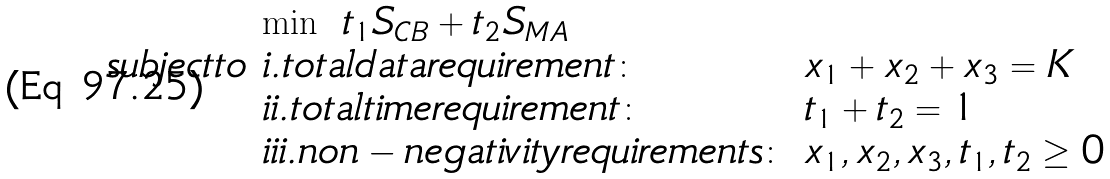Convert formula to latex. <formula><loc_0><loc_0><loc_500><loc_500>\begin{array} { l l l } & \min \ t _ { 1 } S _ { C B } + t _ { 2 } S _ { M A } & \\ s u b j e c t t o & i . t o t a l d a t a r e q u i r e m e n t \colon & x _ { 1 } + x _ { 2 } + x _ { 3 } = K \\ & i i . t o t a l t i m e r e q u i r e m e n t \colon & t _ { 1 } + t _ { 2 } = 1 \\ & i i i . n o n - n e g a t i v i t y r e q u i r e m e n t s \colon & x _ { 1 } , x _ { 2 } , x _ { 3 } , t _ { 1 } , t _ { 2 } \geq 0 \end{array}</formula> 